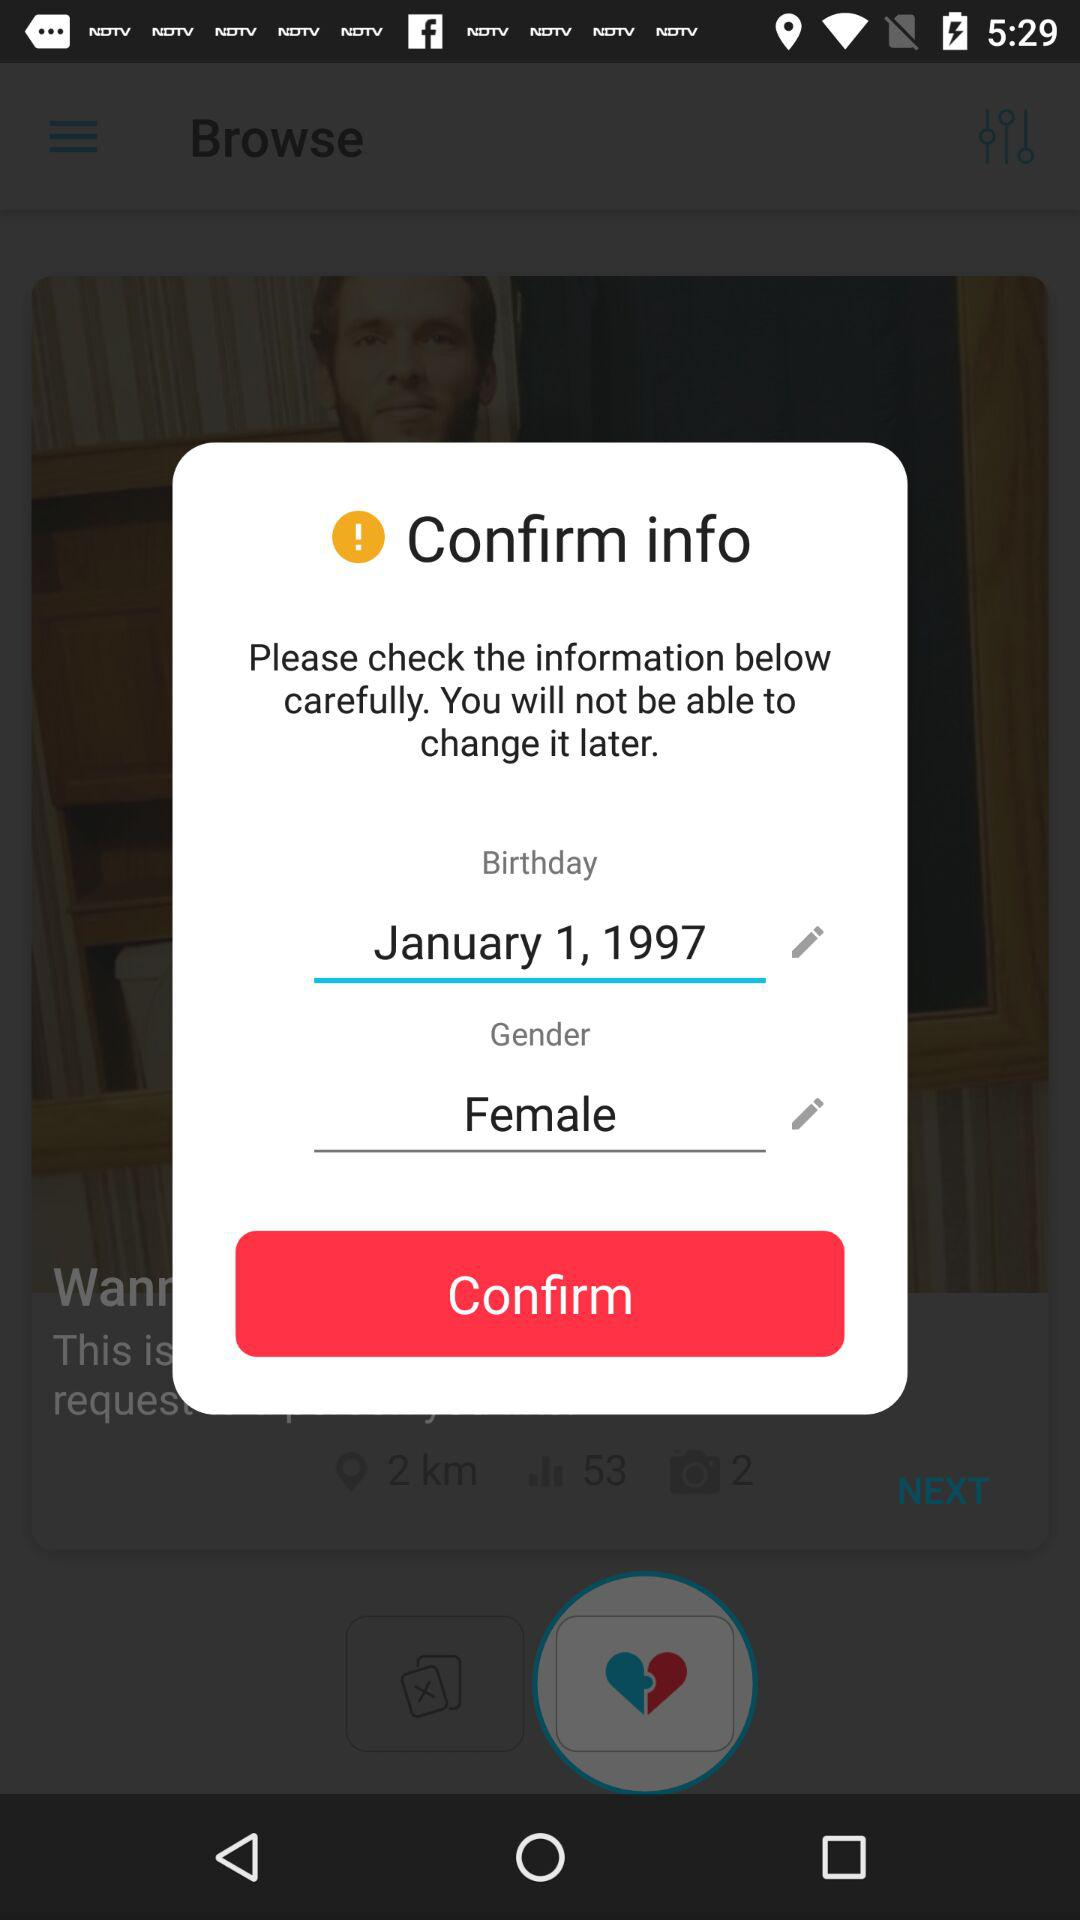What is the gender? The gender is female. 